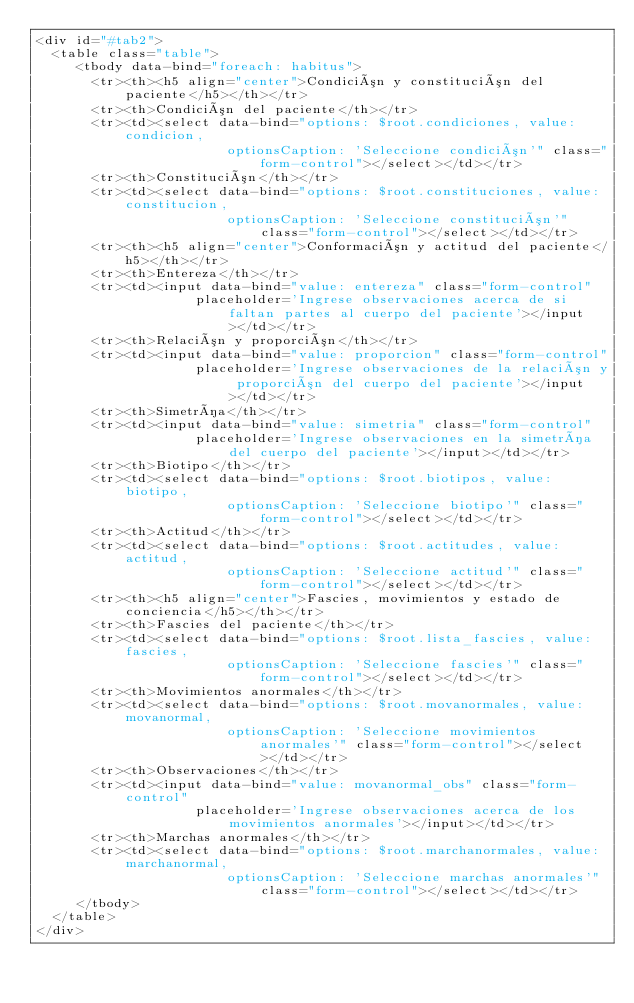Convert code to text. <code><loc_0><loc_0><loc_500><loc_500><_PHP_><div id="#tab2">
  <table class="table">
     <tbody data-bind="foreach: habitus">
       <tr><th><h5 align="center">Condición y constitución del paciente</h5></th></tr>
       <tr><th>Condición del paciente</th></tr>
       <tr><td><select data-bind="options: $root.condiciones, value: condicion,
       					optionsCaption: 'Seleccione condición'" class="form-control"></select></td></tr>
       <tr><th>Constitución</th></tr>
       <tr><td><select data-bind="options: $root.constituciones, value: constitucion,
       					optionsCaption: 'Seleccione constitución'" class="form-control"></select></td></tr>
       <tr><th><h5 align="center">Conformación y actitud del paciente</h5></th></tr>
       <tr><th>Entereza</th></tr>
       <tr><td><input data-bind="value: entereza" class="form-control"
       				placeholder='Ingrese observaciones acerca de si faltan partes al cuerpo del paciente'></input></td></tr>
       <tr><th>Relación y proporción</th></tr>
       <tr><td><input data-bind="value: proporcion" class="form-control"
     				placeholder='Ingrese observaciones de la relación y proporción del cuerpo del paciente'></input></td></tr>
       <tr><th>Simetría</th></tr>
       <tr><td><input data-bind="value: simetria" class="form-control"
       				placeholder='Ingrese observaciones en la simetría del cuerpo del paciente'></input></td></tr>
       <tr><th>Biotipo</th></tr>
       <tr><td><select data-bind="options: $root.biotipos, value: biotipo,
       					optionsCaption: 'Seleccione biotipo'" class="form-control"></select></td></tr>
       <tr><th>Actitud</th></tr>
       <tr><td><select data-bind="options: $root.actitudes, value: actitud,
       					optionsCaption: 'Seleccione actitud'" class="form-control"></select></td></tr>
       <tr><th><h5 align="center">Fascies, movimientos y estado de conciencia</h5></th></tr>
       <tr><th>Fascies del paciente</th></tr>
       <tr><td><select data-bind="options: $root.lista_fascies, value: fascies,
       					optionsCaption: 'Seleccione fascies'" class="form-control"></select></td></tr>
       <tr><th>Movimientos anormales</th></tr>
       <tr><td><select data-bind="options: $root.movanormales, value: movanormal,
       					optionsCaption: 'Seleccione movimientos anormales'" class="form-control"></select></td></tr>
       <tr><th>Observaciones</th></tr>
       <tr><td><input data-bind="value: movanormal_obs" class="form-control"
       				placeholder='Ingrese observaciones acerca de los movimientos anormales'></input></td></tr>
       <tr><th>Marchas anormales</th></tr>
       <tr><td><select data-bind="options: $root.marchanormales, value: marchanormal,
       					optionsCaption: 'Seleccione marchas anormales'" class="form-control"></select></td></tr>
     </tbody>
  </table>
</div>
</code> 